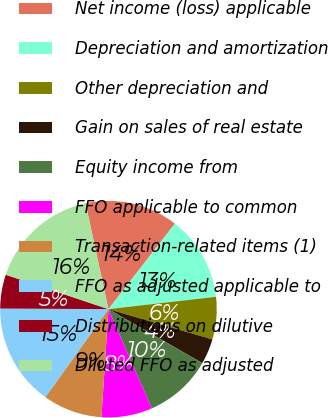<chart> <loc_0><loc_0><loc_500><loc_500><pie_chart><fcel>Net income (loss) applicable<fcel>Depreciation and amortization<fcel>Other depreciation and<fcel>Gain on sales of real estate<fcel>Equity income from<fcel>FFO applicable to common<fcel>Transaction-related items (1)<fcel>FFO as adjusted applicable to<fcel>Distributions on dilutive<fcel>Diluted FFO as adjusted<nl><fcel>13.92%<fcel>12.66%<fcel>6.33%<fcel>3.8%<fcel>10.13%<fcel>7.59%<fcel>8.86%<fcel>15.19%<fcel>5.06%<fcel>16.46%<nl></chart> 